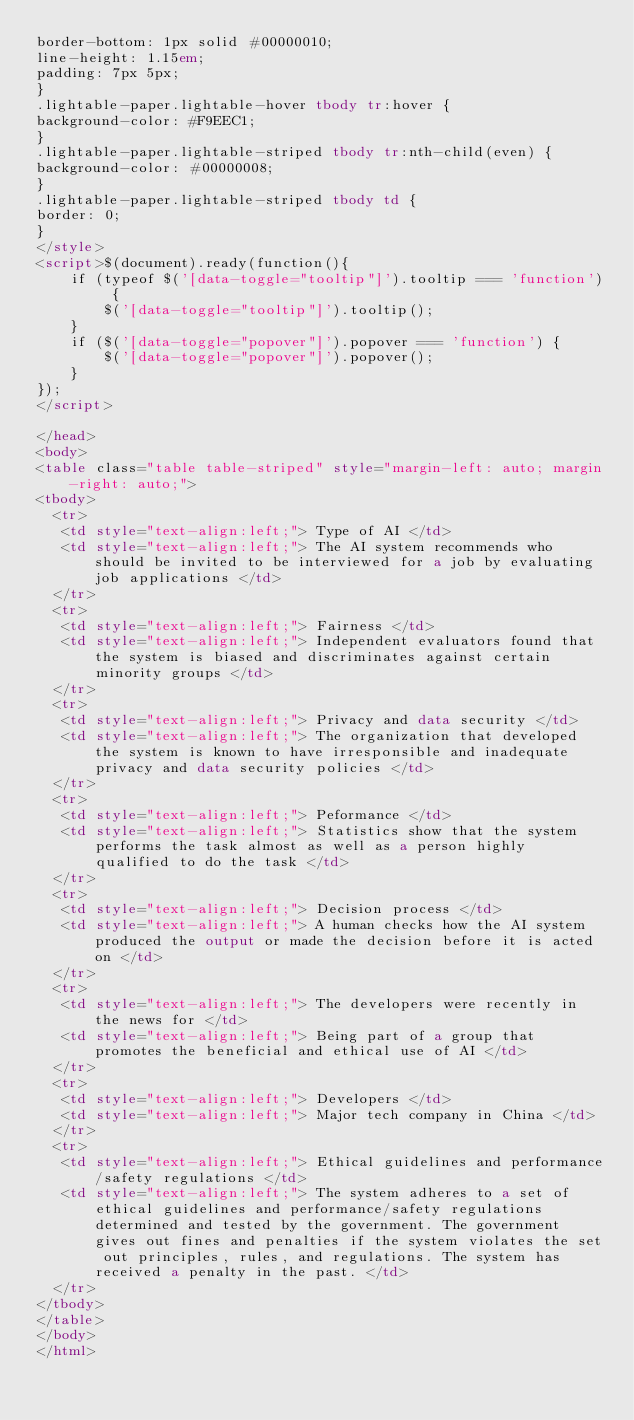<code> <loc_0><loc_0><loc_500><loc_500><_HTML_>border-bottom: 1px solid #00000010;
line-height: 1.15em;
padding: 7px 5px;
}
.lightable-paper.lightable-hover tbody tr:hover {
background-color: #F9EEC1;
}
.lightable-paper.lightable-striped tbody tr:nth-child(even) {
background-color: #00000008;
}
.lightable-paper.lightable-striped tbody td {
border: 0;
}
</style>
<script>$(document).ready(function(){
    if (typeof $('[data-toggle="tooltip"]').tooltip === 'function') {
        $('[data-toggle="tooltip"]').tooltip();
    }
    if ($('[data-toggle="popover"]').popover === 'function') {
        $('[data-toggle="popover"]').popover();
    }
});
</script>

</head>
<body>
<table class="table table-striped" style="margin-left: auto; margin-right: auto;">
<tbody>
  <tr>
   <td style="text-align:left;"> Type of AI </td>
   <td style="text-align:left;"> The AI system recommends who should be invited to be interviewed for a job by evaluating job applications </td>
  </tr>
  <tr>
   <td style="text-align:left;"> Fairness </td>
   <td style="text-align:left;"> Independent evaluators found that the system is biased and discriminates against certain minority groups </td>
  </tr>
  <tr>
   <td style="text-align:left;"> Privacy and data security </td>
   <td style="text-align:left;"> The organization that developed the system is known to have irresponsible and inadequate privacy and data security policies </td>
  </tr>
  <tr>
   <td style="text-align:left;"> Peformance </td>
   <td style="text-align:left;"> Statistics show that the system performs the task almost as well as a person highly qualified to do the task </td>
  </tr>
  <tr>
   <td style="text-align:left;"> Decision process </td>
   <td style="text-align:left;"> A human checks how the AI system produced the output or made the decision before it is acted on </td>
  </tr>
  <tr>
   <td style="text-align:left;"> The developers were recently in the news for </td>
   <td style="text-align:left;"> Being part of a group that promotes the beneficial and ethical use of AI </td>
  </tr>
  <tr>
   <td style="text-align:left;"> Developers </td>
   <td style="text-align:left;"> Major tech company in China </td>
  </tr>
  <tr>
   <td style="text-align:left;"> Ethical guidelines and performance/safety regulations </td>
   <td style="text-align:left;"> The system adheres to a set of ethical guidelines and performance/safety regulations determined and tested by the government. The government gives out fines and penalties if the system violates the set out principles, rules, and regulations. The system has received a penalty in the past. </td>
  </tr>
</tbody>
</table>
</body>
</html>
</code> 